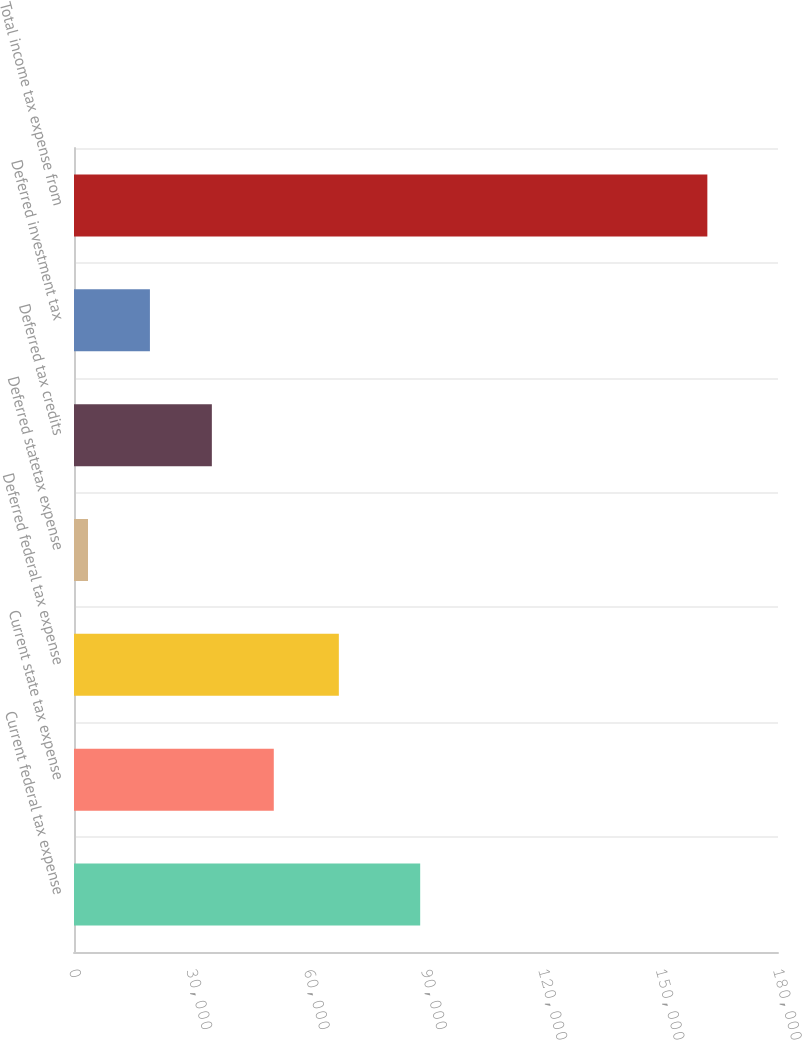Convert chart. <chart><loc_0><loc_0><loc_500><loc_500><bar_chart><fcel>Current federal tax expense<fcel>Current state tax expense<fcel>Deferred federal tax expense<fcel>Deferred statetax expense<fcel>Deferred tax credits<fcel>Deferred investment tax<fcel>Total income tax expense from<nl><fcel>88514<fcel>51082.3<fcel>67716<fcel>3574<fcel>35246.2<fcel>19410.1<fcel>161935<nl></chart> 